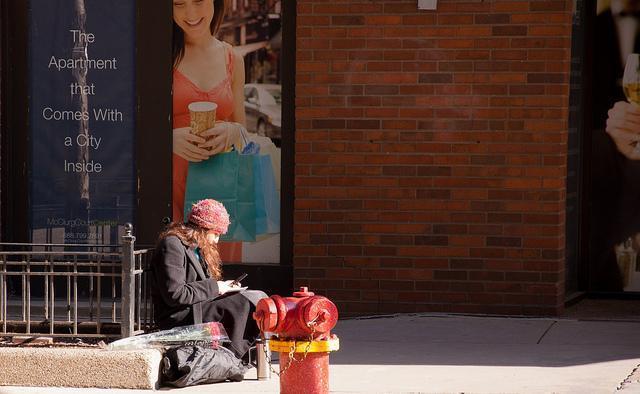How many people can be seen?
Give a very brief answer. 3. How many fire hydrants can be seen?
Give a very brief answer. 1. 